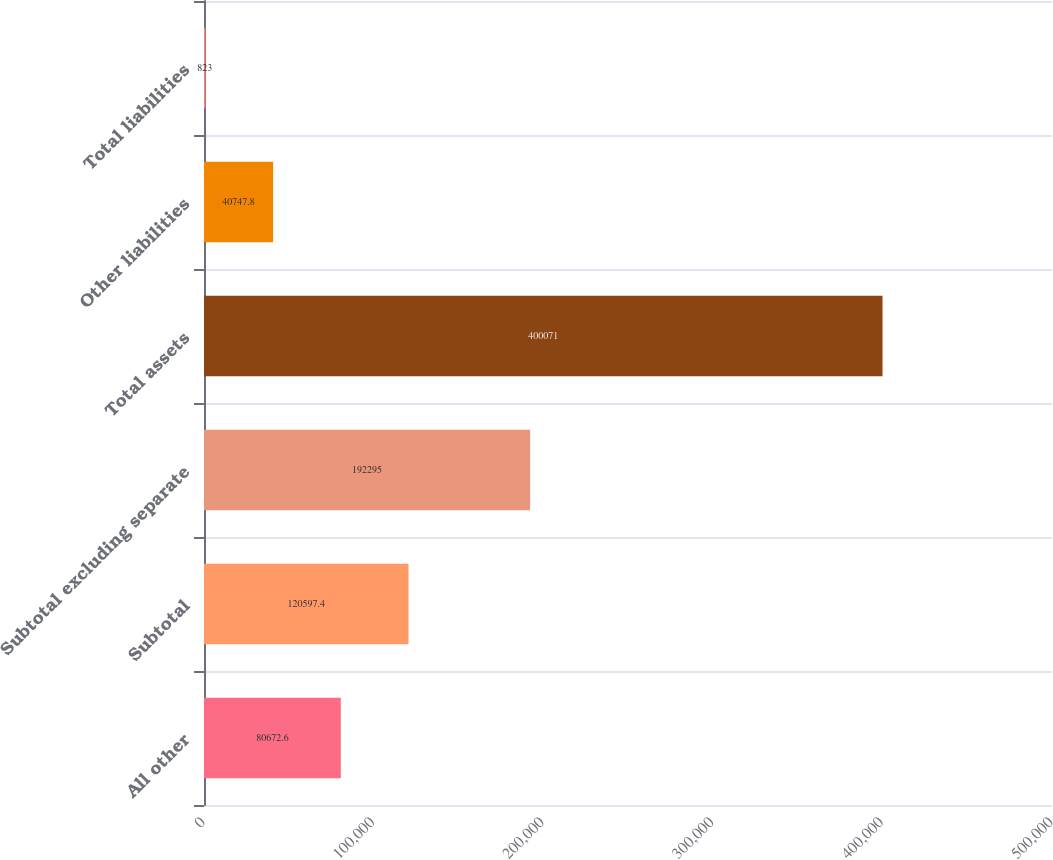Convert chart. <chart><loc_0><loc_0><loc_500><loc_500><bar_chart><fcel>All other<fcel>Subtotal<fcel>Subtotal excluding separate<fcel>Total assets<fcel>Other liabilities<fcel>Total liabilities<nl><fcel>80672.6<fcel>120597<fcel>192295<fcel>400071<fcel>40747.8<fcel>823<nl></chart> 